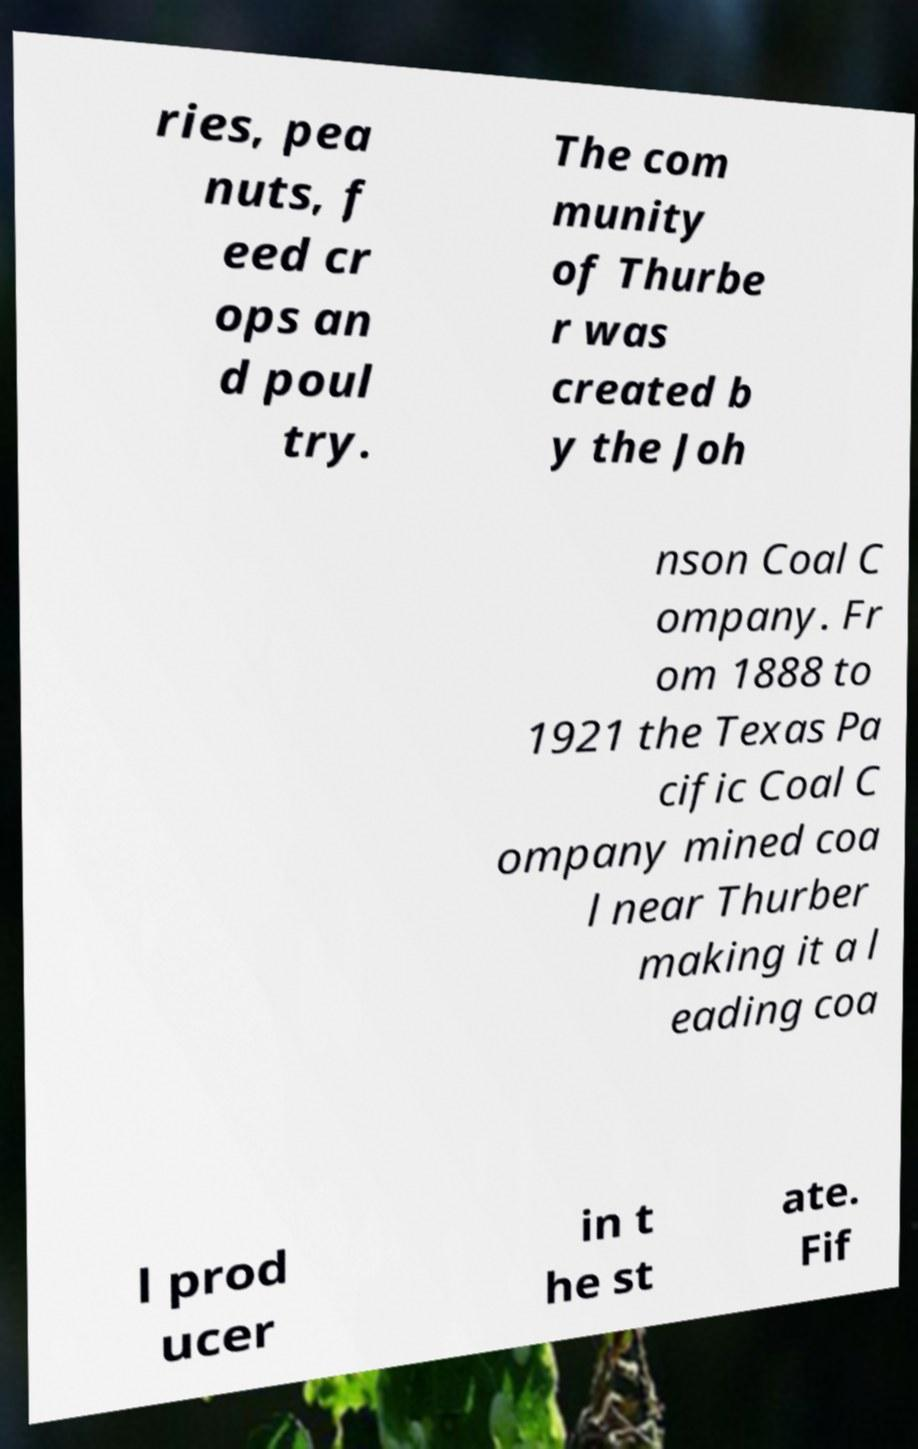There's text embedded in this image that I need extracted. Can you transcribe it verbatim? ries, pea nuts, f eed cr ops an d poul try. The com munity of Thurbe r was created b y the Joh nson Coal C ompany. Fr om 1888 to 1921 the Texas Pa cific Coal C ompany mined coa l near Thurber making it a l eading coa l prod ucer in t he st ate. Fif 